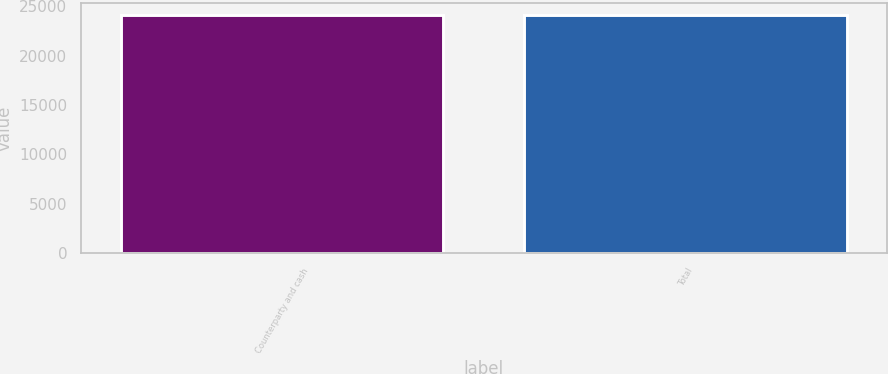Convert chart. <chart><loc_0><loc_0><loc_500><loc_500><bar_chart><fcel>Counterparty and cash<fcel>Total<nl><fcel>24161<fcel>24161.1<nl></chart> 